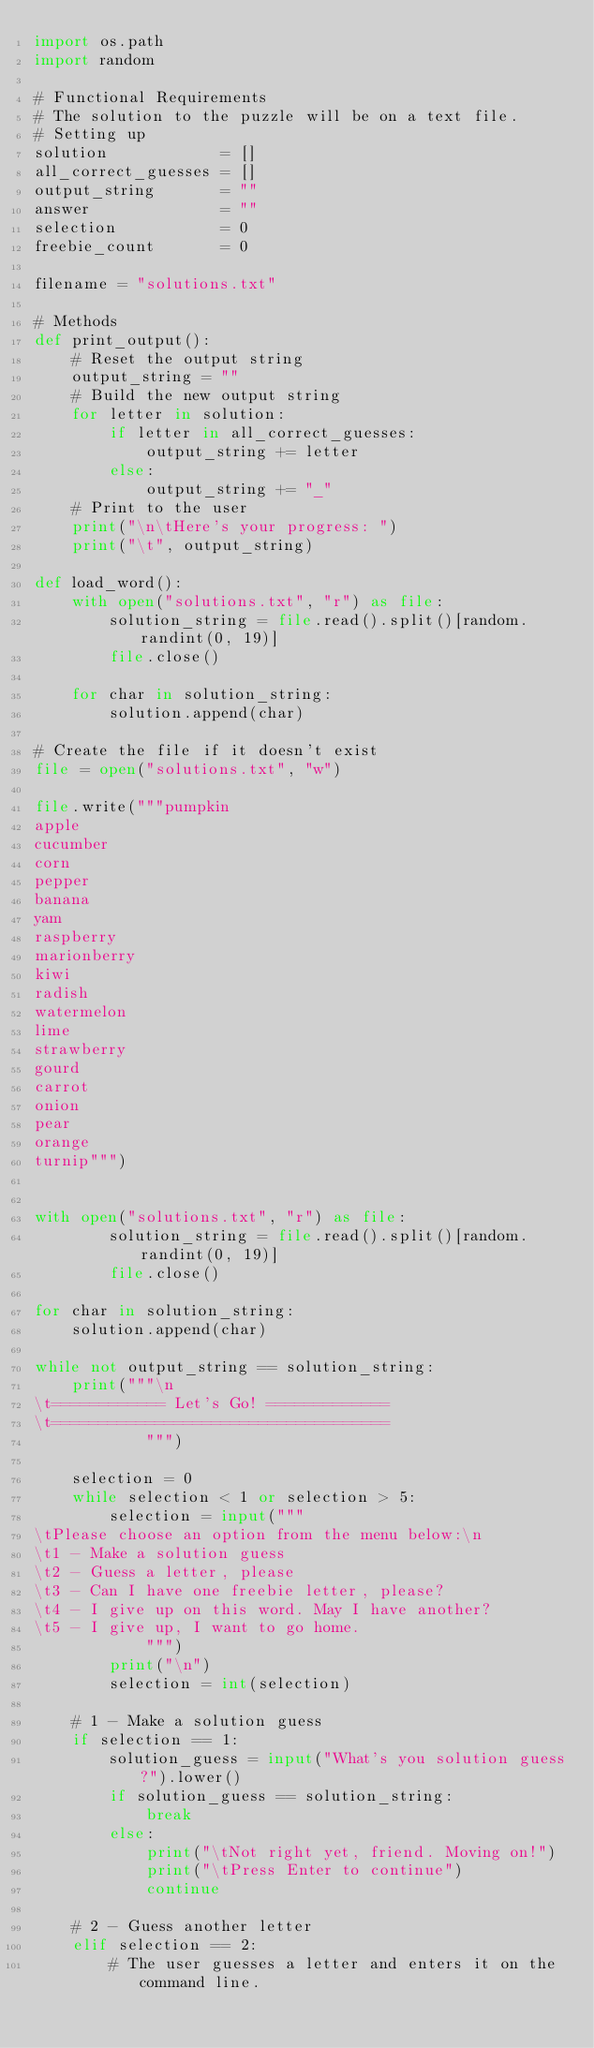Convert code to text. <code><loc_0><loc_0><loc_500><loc_500><_Python_>import os.path
import random

# Functional Requirements
# The solution to the puzzle will be on a text file.
# Setting up
solution            = []
all_correct_guesses = []
output_string       = ""
answer              = ""
selection           = 0
freebie_count       = 0

filename = "solutions.txt"

# Methods
def print_output():
    # Reset the output string
    output_string = ""
    # Build the new output string
    for letter in solution:
        if letter in all_correct_guesses:
            output_string += letter
        else:
            output_string += "_"
    # Print to the user
    print("\n\tHere's your progress: ")
    print("\t", output_string)

def load_word():
    with open("solutions.txt", "r") as file:
        solution_string = file.read().split()[random.randint(0, 19)]
        file.close()

    for char in solution_string:
        solution.append(char)

# Create the file if it doesn't exist
file = open("solutions.txt", "w")

file.write("""pumpkin
apple
cucumber
corn
pepper
banana
yam
raspberry
marionberry
kiwi
radish
watermelon
lime
strawberry
gourd
carrot
onion
pear
orange
turnip""")


with open("solutions.txt", "r") as file:
        solution_string = file.read().split()[random.randint(0, 19)]
        file.close()

for char in solution_string:
    solution.append(char)

while not output_string == solution_string:
    print("""\n
\t============ Let's Go! =============
\t====================================
            """)

    selection = 0
    while selection < 1 or selection > 5:
        selection = input("""
\tPlease choose an option from the menu below:\n
\t1 - Make a solution guess
\t2 - Guess a letter, please
\t3 - Can I have one freebie letter, please?
\t4 - I give up on this word. May I have another?
\t5 - I give up, I want to go home.
            """)
        print("\n")
        selection = int(selection)

    # 1 - Make a solution guess
    if selection == 1:
        solution_guess = input("What's you solution guess?").lower()
        if solution_guess == solution_string:
            break
        else:
            print("\tNot right yet, friend. Moving on!")
            print("\tPress Enter to continue")
            continue

    # 2 - Guess another letter
    elif selection == 2:
        # The user guesses a letter and enters it on the command line.</code> 